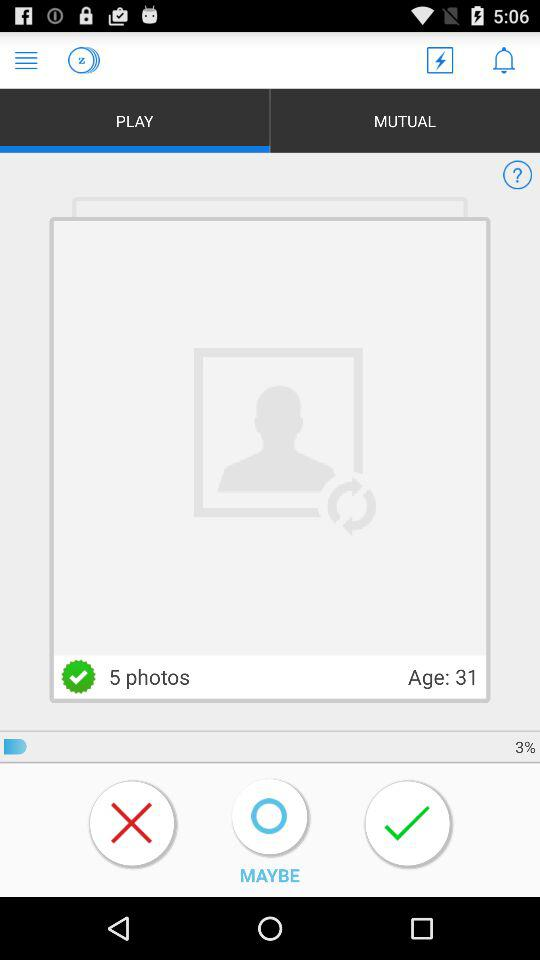Which tab is selected? The selected tab is "PLAY". 